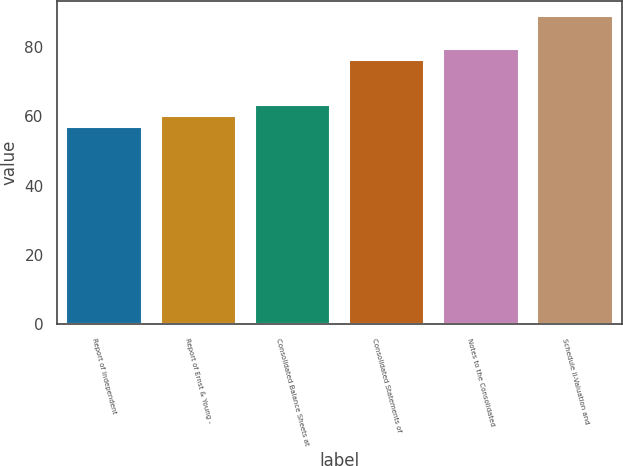Convert chart to OTSL. <chart><loc_0><loc_0><loc_500><loc_500><bar_chart><fcel>Report of Independent<fcel>Report of Ernst & Young -<fcel>Consolidated Balance Sheets at<fcel>Consolidated Statements of<fcel>Notes to the Consolidated<fcel>Schedule II-Valuation and<nl><fcel>57<fcel>60.2<fcel>63.4<fcel>76.2<fcel>79.4<fcel>89<nl></chart> 